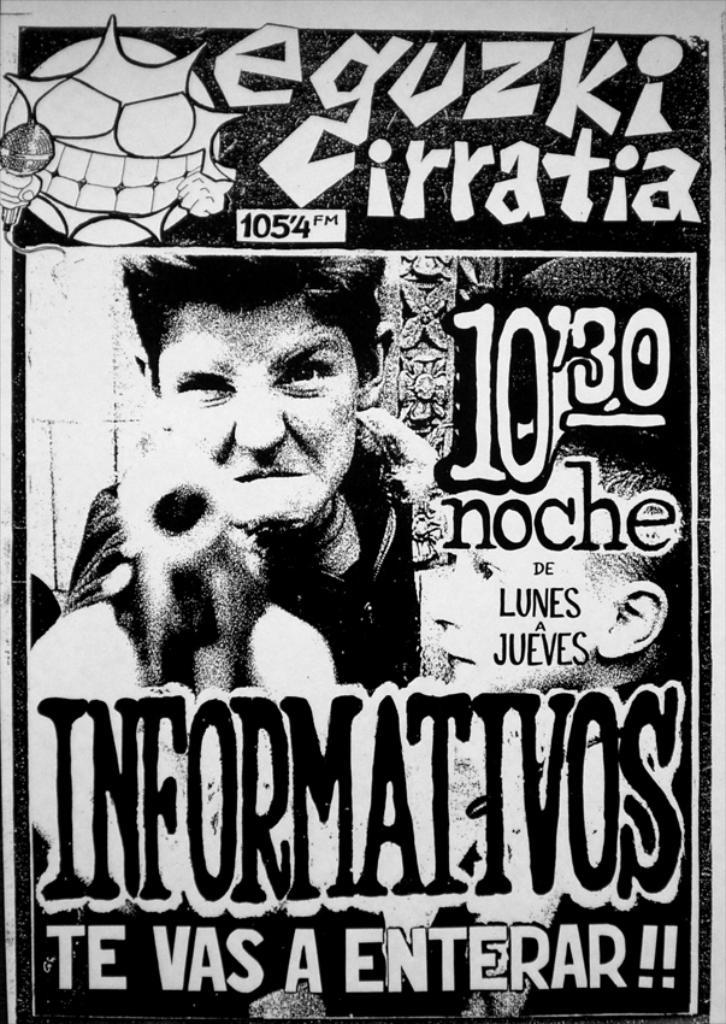<image>
Present a compact description of the photo's key features. A poster with a guy with a gun on it for Eguzke Cirratia. 